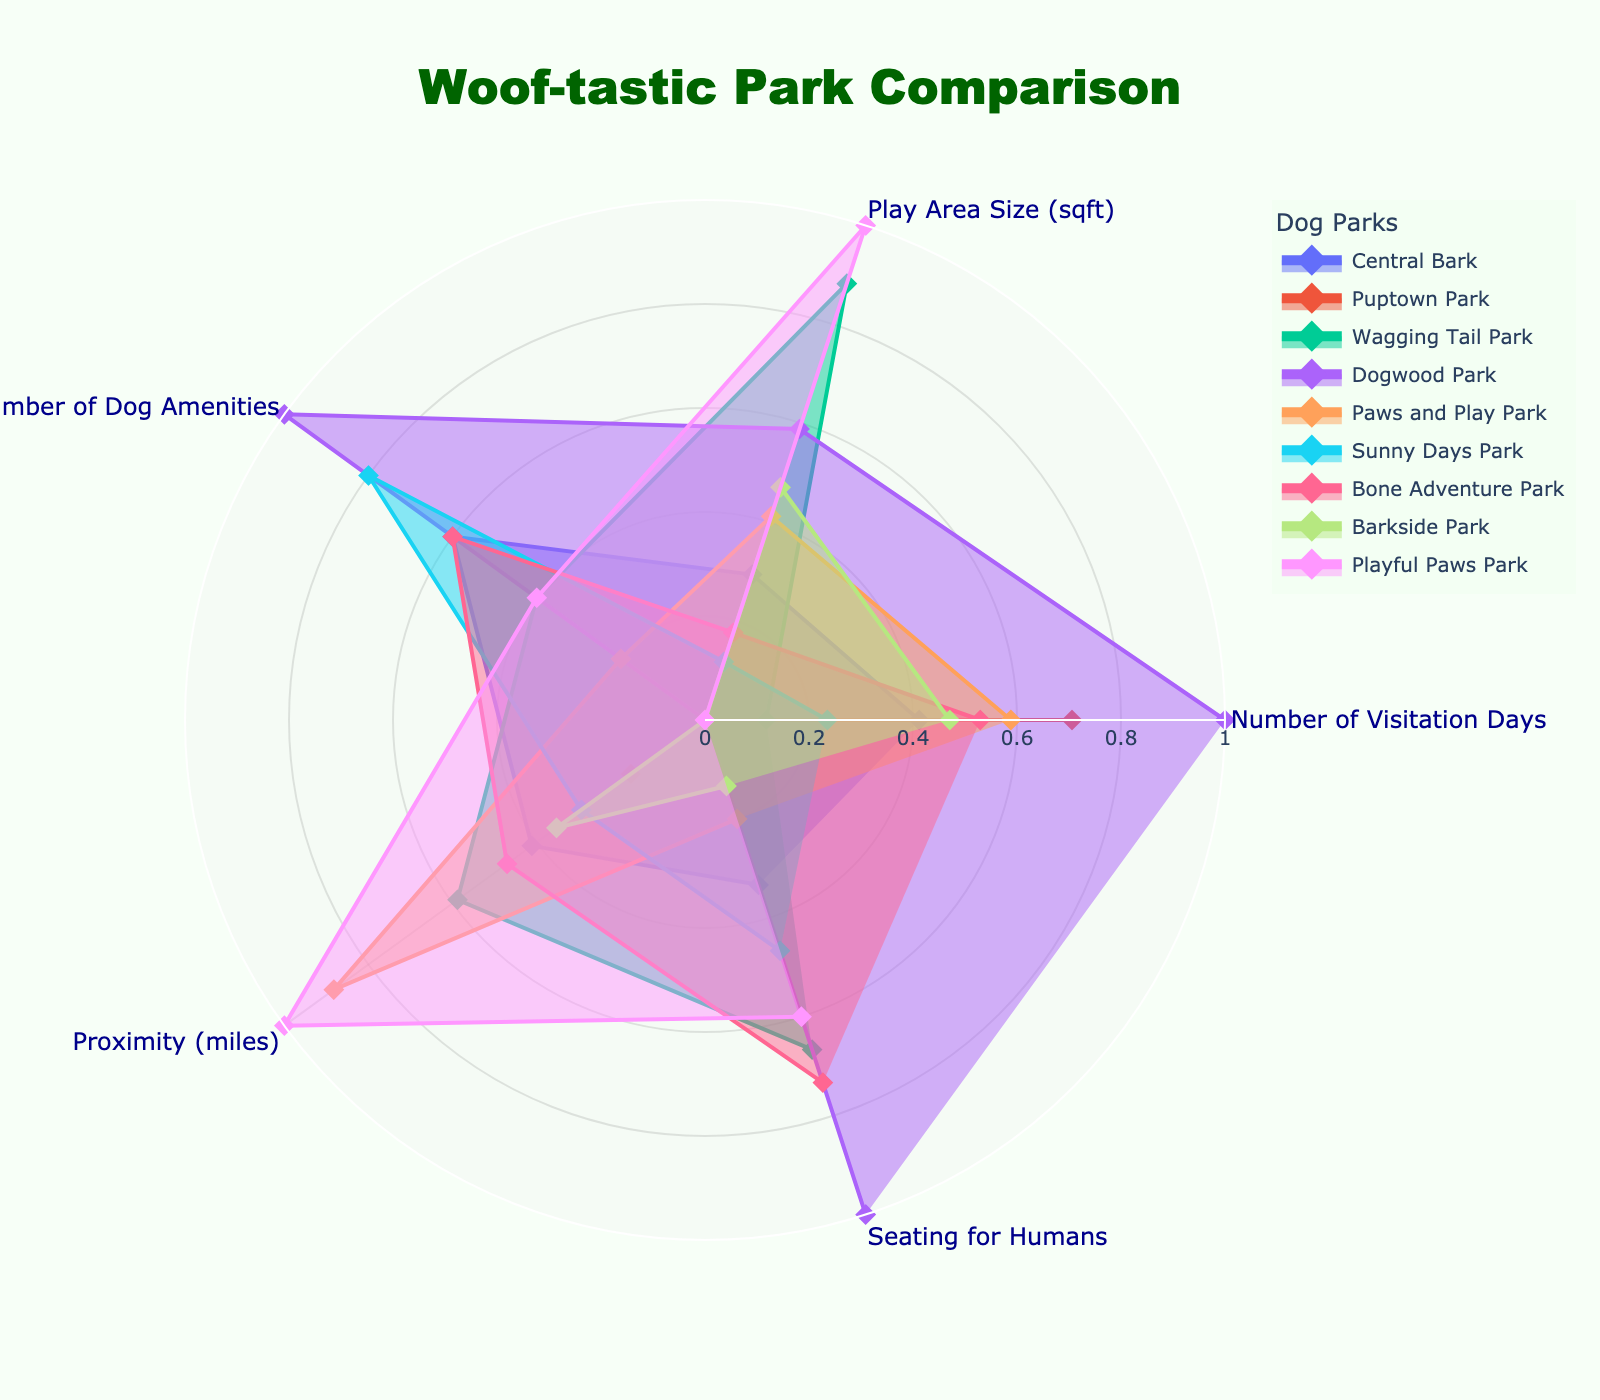what is the title of the radar chart? The title can be found at the top of the radar chart.
Answer: Woof-tastic Park Comparison what are the categories compared in the radar chart? The categories are listed as the axes of the radar chart.
Answer: Number of Visitation Days, Play Area Size (sqft), Number of Dog Amenities, Proximity (miles), Seating for Humans which park has the highest Number of Visitation Days? By looking at the axis for Number of Visitation Days, the park with the largest value is identified.
Answer: Dogwood Park what is the range of the radial axis in the radar chart? The range of the radial axis can be determined by looking at the scale on the radar chart.
Answer: 0 to 1 compare the Seating for Humans between Central Bark and Wagging Tail Park. Look at the axis for Seating for Humans and compare the values for both parks.
Answer: Wagging Tail Park has more seating which park is the closest in proximity? The park with the smallest value on the Proximity axis is the closest.
Answer: Dogwood Park do any two parks have equal Number of Dog Amenities? Compare the values on the Number of Dog Amenities axis for all parks to find any equal values.
Answer: Yes, Central Bark and Bone Adventure Park which park has the largest Play Area Size? Look at the Play Area Size axis and find the park with the highest value.
Answer: Playful Paws Park how does Puptown Park compare to Sunny Days Park in Number of Visitation Days and Seating for Humans? Compare the values for Puptown Park and Sunny Days Park on the Number of Visitation Days and Seating for Humans axes.
Answer: Puptown Park has more visitation days, but Sunny Days Park has more seating which park has the highest values in almost every category? Identify the park with the highest or near-highest values in most categories by examining each axis.
Answer: Dogwood Park 